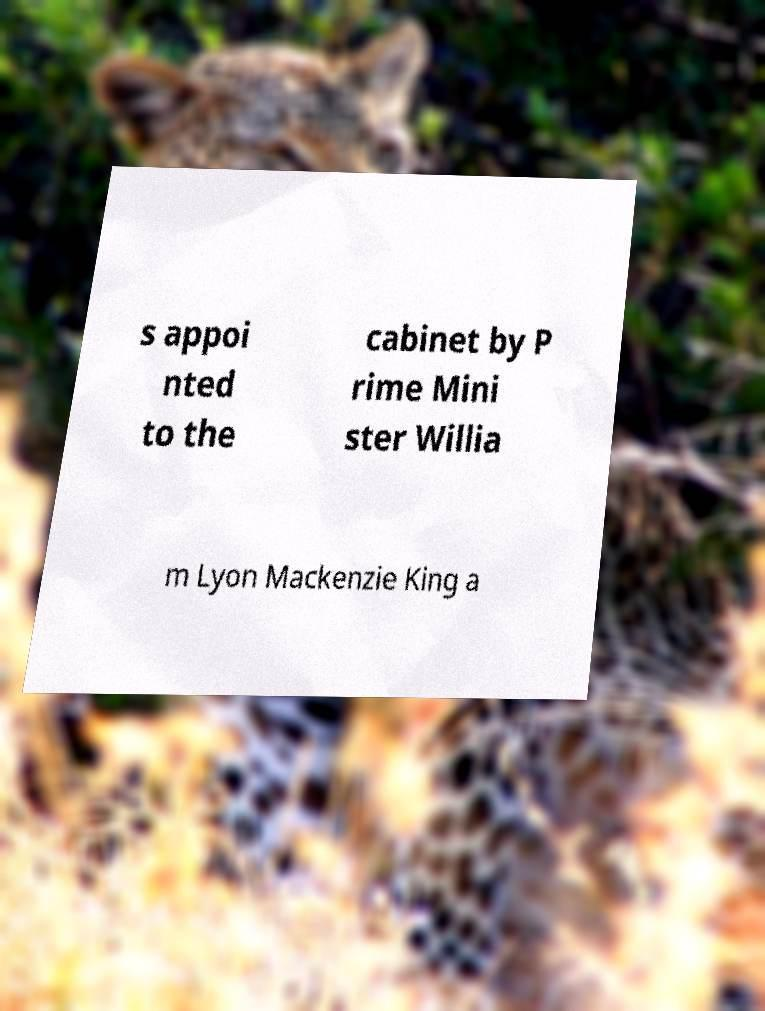Can you accurately transcribe the text from the provided image for me? s appoi nted to the cabinet by P rime Mini ster Willia m Lyon Mackenzie King a 